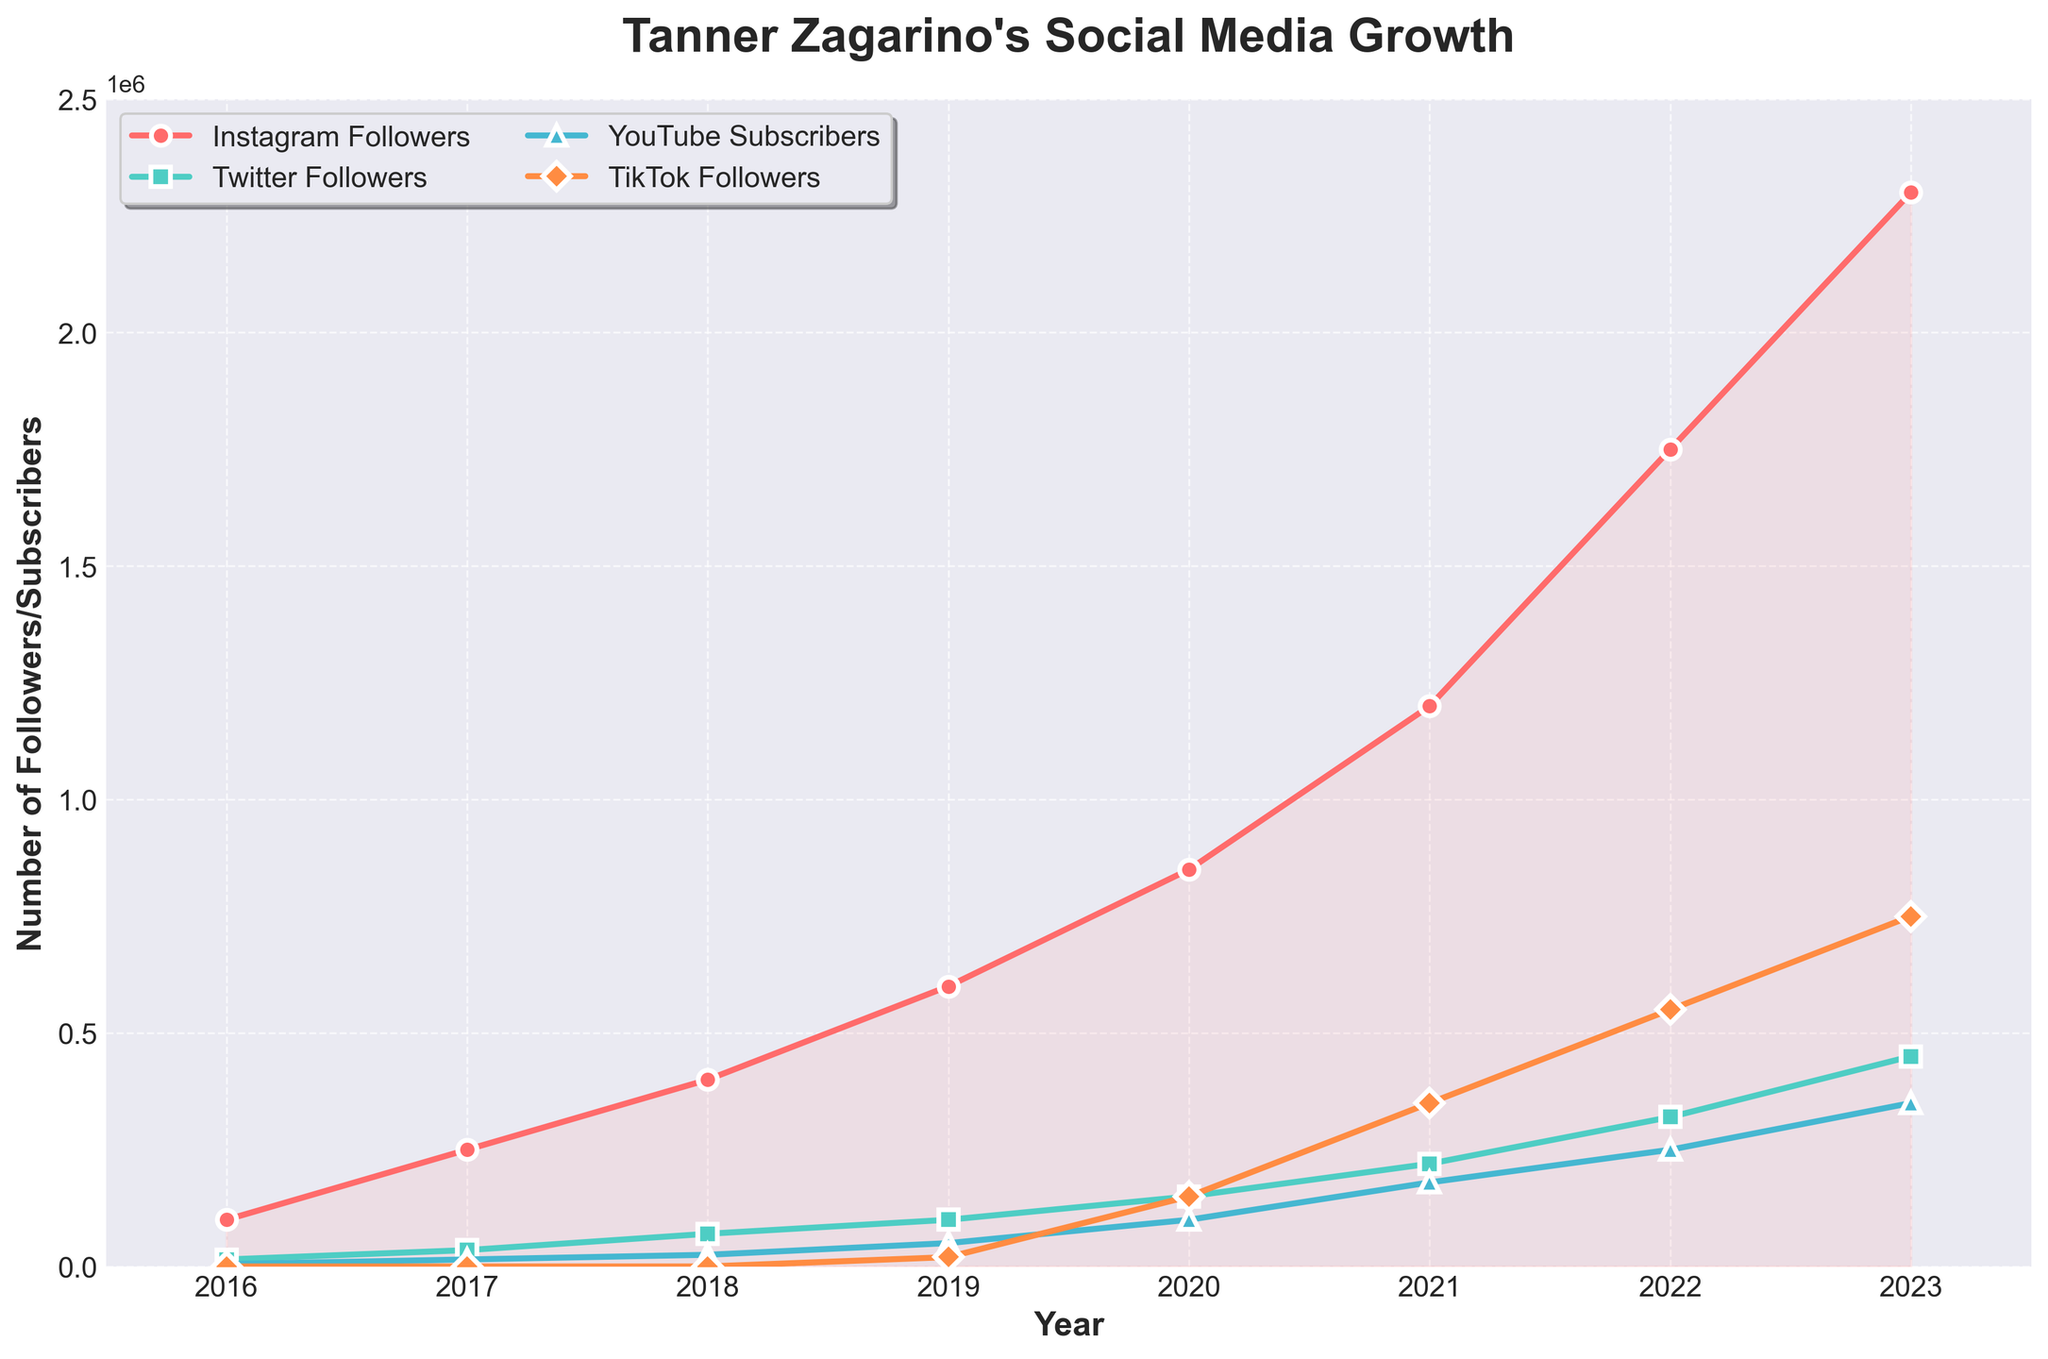What's the title of the plot? The title is found at the top of the plot and usually provides a summary of what the plot represents. In this plot, it reads "Tanner Zagarino's Social Media Growth".
Answer: Tanner Zagarino's Social Media Growth How many different social media platforms are represented in the plot? The legend and different colored lines on the plot represent each social media platform. There are four lines and colors, denoting Instagram, Twitter, YouTube, and TikTok.
Answer: Four Which social media platform had the most significant growth in followers/subscribers between 2016 and 2023? Observing the plot lines, the one with the steepest increase signifies the most significant growth. Instagram Followers line shows the steepest increase from 100,000 in 2016 to 2,300,000 in 2023.
Answer: Instagram How much did TikTok followers increase between 2019 and 2023? To find this, look at the TikTok line for the values in 2019 and 2023, then subtract the 2019 values from the 2023 values. TikTok followers increased from 20,000 in 2019 to 750,000 in 2023. This equals 750,000 - 20,000.
Answer: 730,000 What year did YouTube subscribers reach 100,000? By following the YouTube subscribers line and noting where it crosses the 100,000 mark on the y-axis, it is clear that this happens in the year 2020.
Answer: 2020 Compare the number of Twitter followers in 2017 and 2023. Which year had more and by how much? Look at the Twitter followers line at both 2017 and 2023 points and compare their heights. In 2017, there were 35,000 followers, while in 2023, there were 450,000. Subtract 35,000 from 450,000 to find the difference.
Answer: 2023 had more by 415,000 Between 2020 and 2022, which social media platform saw the highest increase in followers/subscribers? Calculate the change in followers/subscribers for each platform between these years. For Instagram, it increased from 850,000 to 1,750,000 (900,000 increase); for Twitter from 150,000 to 320,000 (170,000 increase); for YouTube from 100,000 to 250,000 (150,000 increase); and for TikTok from 150,000 to 550,000 (400,000 increase). Instagram had the highest increase.
Answer: Instagram Which year saw the biggest jump in Instagram followers? Checking the incremental values year by year on the Instagram line, the largest jump occurred between 2021 and 2022, going from 1,200,000 to 1,750,000, indicating a rise of 550,000.
Answer: 2022 What overall trend does the plot display regarding the popularity growth of Tanner Zagarino on social media platforms? Observing all the lines' general movement from left to right, they all show an increasing trend, indicating consistent growth in followers/subscribers on all platforms over the years.
Answer: Increasing growth Approximately how many followers did Tanner Zagarino have across all platforms in 2021? Add the number of followers from all platforms for 2021. Instagram: 1,200,000, Twitter: 220,000, YouTube: 180,000, TikTok: 350,000. The total is 1,200,000 + 220,000 + 180,000 + 350,000.
Answer: 1,950,000 